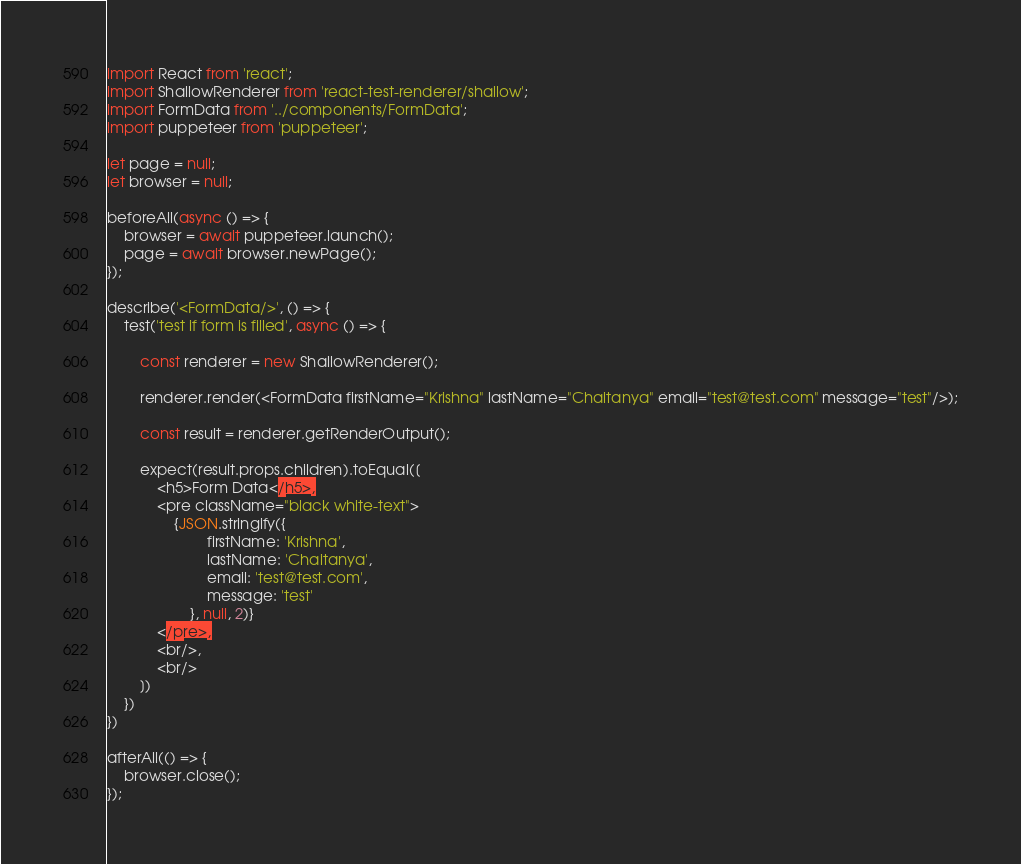<code> <loc_0><loc_0><loc_500><loc_500><_JavaScript_>import React from 'react';
import ShallowRenderer from 'react-test-renderer/shallow';
import FormData from '../components/FormData';
import puppeteer from 'puppeteer';

let page = null;
let browser = null;

beforeAll(async () => {
    browser = await puppeteer.launch();
    page = await browser.newPage();
});

describe('<FormData/>', () => {
    test('test if form is filled', async () => {

        const renderer = new ShallowRenderer();

        renderer.render(<FormData firstName="Krishna" lastName="Chaitanya" email="test@test.com" message="test"/>);

        const result = renderer.getRenderOutput();

        expect(result.props.children).toEqual([
            <h5>Form Data</h5>,
            <pre className="black white-text">
                {JSON.stringify({
                        firstName: 'Krishna',
                        lastName: 'Chaitanya',
                        email: 'test@test.com',
                        message: 'test'
                    }, null, 2)}
            </pre>,
            <br/>,
            <br/>
        ])
    })
})

afterAll(() => {
    browser.close();
});</code> 